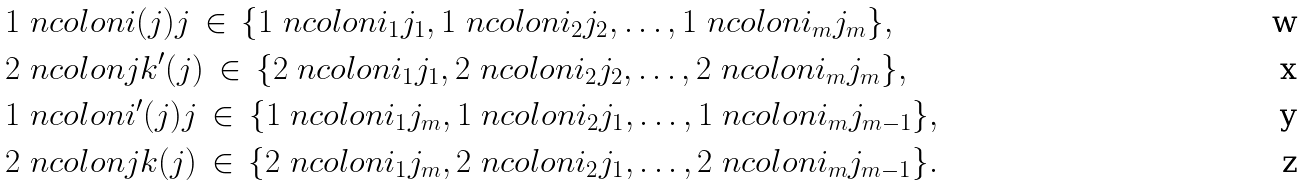Convert formula to latex. <formula><loc_0><loc_0><loc_500><loc_500>& 1 \ n c o l o n i ( j ) j \, \in \, \{ 1 \ n c o l o n i _ { 1 } j _ { 1 } , 1 \ n c o l o n i _ { 2 } j _ { 2 } , \dots , 1 \ n c o l o n i _ { m } j _ { m } \} , \\ & 2 \ n c o l o n j k ^ { \prime } ( j ) \, \in \, \{ 2 \ n c o l o n i _ { 1 } j _ { 1 } , 2 \ n c o l o n i _ { 2 } j _ { 2 } , \dots , 2 \ n c o l o n i _ { m } j _ { m } \} , \\ & 1 \ n c o l o n i ^ { \prime } ( j ) j \, \in \, \{ 1 \ n c o l o n i _ { 1 } j _ { m } , 1 \ n c o l o n i _ { 2 } j _ { 1 } , \dots , 1 \ n c o l o n i _ { m } j _ { m - 1 } \} , \\ & 2 \ n c o l o n j k ( j ) \, \in \, \{ 2 \ n c o l o n i _ { 1 } j _ { m } , 2 \ n c o l o n i _ { 2 } j _ { 1 } , \dots , 2 \ n c o l o n i _ { m } j _ { m - 1 } \} .</formula> 